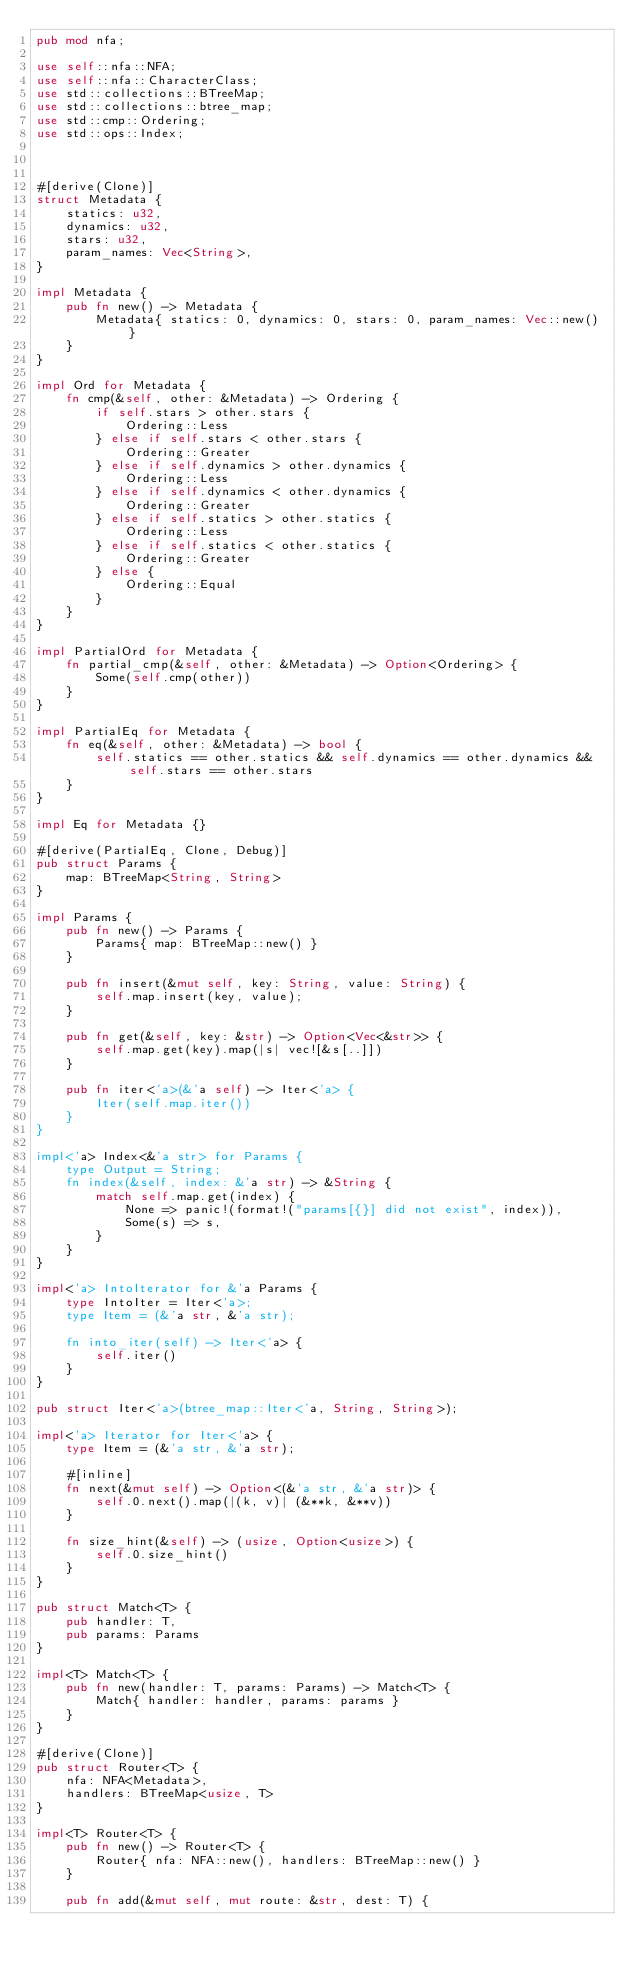<code> <loc_0><loc_0><loc_500><loc_500><_Rust_>pub mod nfa;

use self::nfa::NFA;
use self::nfa::CharacterClass;
use std::collections::BTreeMap;
use std::collections::btree_map;
use std::cmp::Ordering;
use std::ops::Index;



#[derive(Clone)]
struct Metadata {
    statics: u32,
    dynamics: u32,
    stars: u32,
    param_names: Vec<String>,
}

impl Metadata {
    pub fn new() -> Metadata {
        Metadata{ statics: 0, dynamics: 0, stars: 0, param_names: Vec::new() }
    }
}

impl Ord for Metadata {
    fn cmp(&self, other: &Metadata) -> Ordering {
        if self.stars > other.stars {
            Ordering::Less
        } else if self.stars < other.stars {
            Ordering::Greater
        } else if self.dynamics > other.dynamics {
            Ordering::Less
        } else if self.dynamics < other.dynamics {
            Ordering::Greater
        } else if self.statics > other.statics {
            Ordering::Less
        } else if self.statics < other.statics {
            Ordering::Greater
        } else {
            Ordering::Equal
        }
    }
}

impl PartialOrd for Metadata {
    fn partial_cmp(&self, other: &Metadata) -> Option<Ordering> {
        Some(self.cmp(other))
    }
}

impl PartialEq for Metadata {
    fn eq(&self, other: &Metadata) -> bool {
        self.statics == other.statics && self.dynamics == other.dynamics && self.stars == other.stars
    }
}

impl Eq for Metadata {}

#[derive(PartialEq, Clone, Debug)]
pub struct Params {
    map: BTreeMap<String, String>
}

impl Params {
    pub fn new() -> Params {
        Params{ map: BTreeMap::new() }
    }

    pub fn insert(&mut self, key: String, value: String) {
        self.map.insert(key, value);
    }

    pub fn get(&self, key: &str) -> Option<Vec<&str>> {
        self.map.get(key).map(|s| vec![&s[..]])
    }

    pub fn iter<'a>(&'a self) -> Iter<'a> {
        Iter(self.map.iter())
    }
}

impl<'a> Index<&'a str> for Params {
    type Output = String;
    fn index(&self, index: &'a str) -> &String {
        match self.map.get(index) {
            None => panic!(format!("params[{}] did not exist", index)),
            Some(s) => s,
        }
    }
}

impl<'a> IntoIterator for &'a Params {
    type IntoIter = Iter<'a>;
    type Item = (&'a str, &'a str);

    fn into_iter(self) -> Iter<'a> {
        self.iter()
    }
}

pub struct Iter<'a>(btree_map::Iter<'a, String, String>);

impl<'a> Iterator for Iter<'a> {
    type Item = (&'a str, &'a str);

    #[inline]
    fn next(&mut self) -> Option<(&'a str, &'a str)> {
        self.0.next().map(|(k, v)| (&**k, &**v))
    }

    fn size_hint(&self) -> (usize, Option<usize>) {
        self.0.size_hint()
    }
}

pub struct Match<T> {
    pub handler: T,
    pub params: Params
}

impl<T> Match<T> {
    pub fn new(handler: T, params: Params) -> Match<T> {
        Match{ handler: handler, params: params }
    }
}

#[derive(Clone)]
pub struct Router<T> {
    nfa: NFA<Metadata>,
    handlers: BTreeMap<usize, T>
}

impl<T> Router<T> {
    pub fn new() -> Router<T> {
        Router{ nfa: NFA::new(), handlers: BTreeMap::new() }
    }

    pub fn add(&mut self, mut route: &str, dest: T) {</code> 